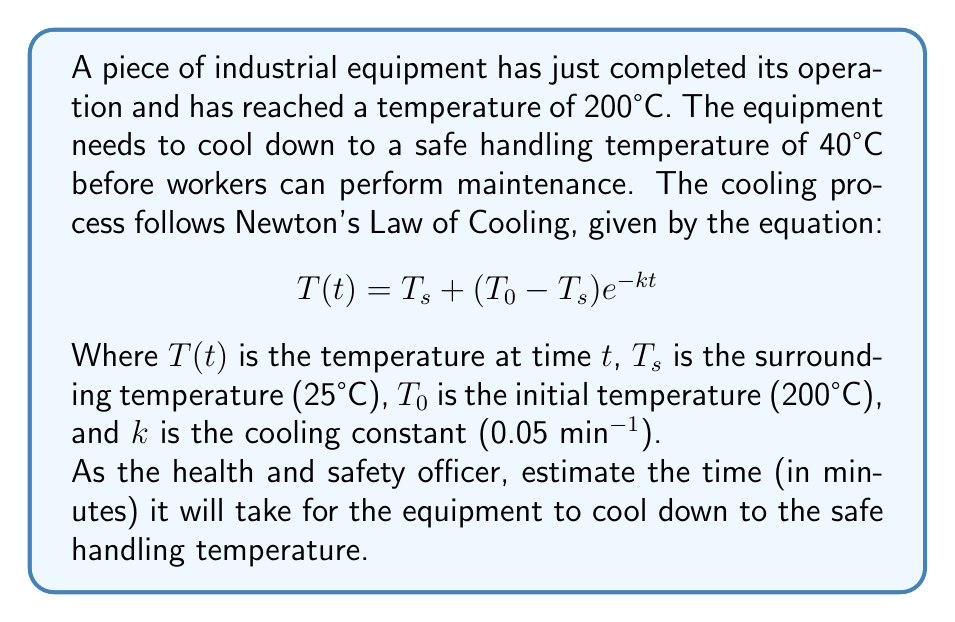Show me your answer to this math problem. To solve this problem, we'll use Newton's Law of Cooling and solve for t:

1) We start with the equation:
   $$T(t) = T_s + (T_0 - T_s)e^{-kt}$$

2) We know:
   $T(t) = 40°C$ (safe handling temperature)
   $T_s = 25°C$ (surrounding temperature)
   $T_0 = 200°C$ (initial temperature)
   $k = 0.05 \text{ min}^{-1}$ (cooling constant)

3) Substitute these values into the equation:
   $$40 = 25 + (200 - 25)e^{-0.05t}$$

4) Simplify:
   $$40 = 25 + 175e^{-0.05t}$$

5) Subtract 25 from both sides:
   $$15 = 175e^{-0.05t}$$

6) Divide both sides by 175:
   $$\frac{15}{175} = e^{-0.05t}$$

7) Take the natural logarithm of both sides:
   $$\ln(\frac{15}{175}) = -0.05t$$

8) Solve for t:
   $$t = -\frac{\ln(\frac{15}{175})}{0.05}$$

9) Calculate the result:
   $$t \approx 48.1 \text{ minutes}$$

10) Round up to the nearest minute for safety:
    $$t = 49 \text{ minutes}$$
Answer: 49 minutes 